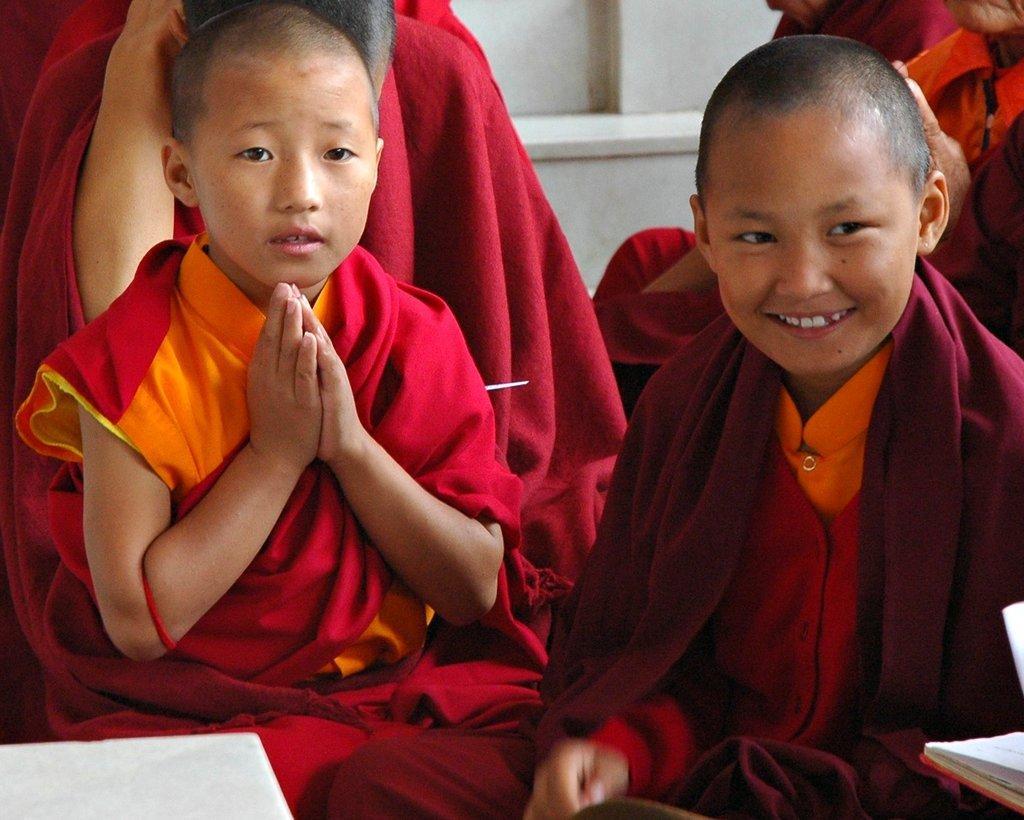Can you describe this image briefly? In the picture we can see two boys who are studying in a preaching school. These guys are wearing a red salwar and an orange shirt. The guy on the right side is having a smile on his face. These two guys are sitting. In the background, there are some people with the same attire. We can observe a wall here. In the right bottom corner there is a book opened. 